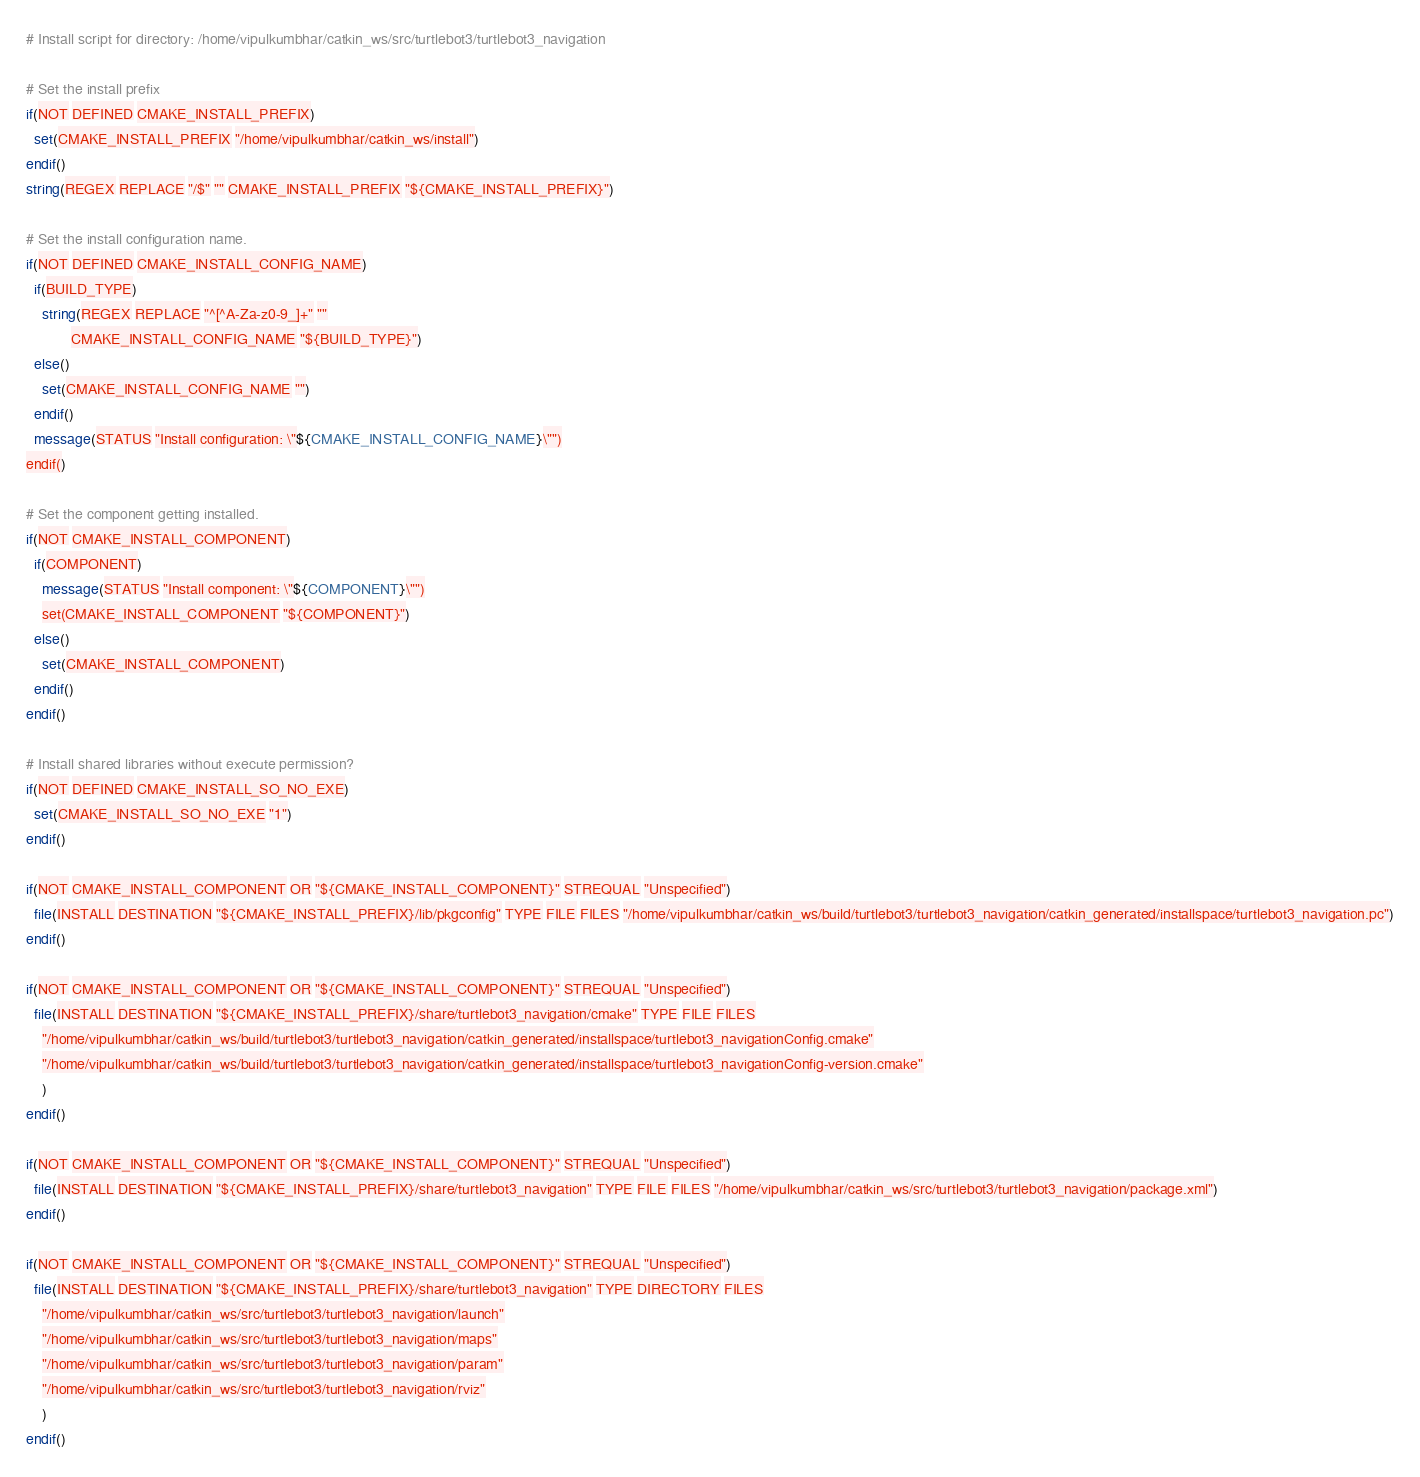Convert code to text. <code><loc_0><loc_0><loc_500><loc_500><_CMake_># Install script for directory: /home/vipulkumbhar/catkin_ws/src/turtlebot3/turtlebot3_navigation

# Set the install prefix
if(NOT DEFINED CMAKE_INSTALL_PREFIX)
  set(CMAKE_INSTALL_PREFIX "/home/vipulkumbhar/catkin_ws/install")
endif()
string(REGEX REPLACE "/$" "" CMAKE_INSTALL_PREFIX "${CMAKE_INSTALL_PREFIX}")

# Set the install configuration name.
if(NOT DEFINED CMAKE_INSTALL_CONFIG_NAME)
  if(BUILD_TYPE)
    string(REGEX REPLACE "^[^A-Za-z0-9_]+" ""
           CMAKE_INSTALL_CONFIG_NAME "${BUILD_TYPE}")
  else()
    set(CMAKE_INSTALL_CONFIG_NAME "")
  endif()
  message(STATUS "Install configuration: \"${CMAKE_INSTALL_CONFIG_NAME}\"")
endif()

# Set the component getting installed.
if(NOT CMAKE_INSTALL_COMPONENT)
  if(COMPONENT)
    message(STATUS "Install component: \"${COMPONENT}\"")
    set(CMAKE_INSTALL_COMPONENT "${COMPONENT}")
  else()
    set(CMAKE_INSTALL_COMPONENT)
  endif()
endif()

# Install shared libraries without execute permission?
if(NOT DEFINED CMAKE_INSTALL_SO_NO_EXE)
  set(CMAKE_INSTALL_SO_NO_EXE "1")
endif()

if(NOT CMAKE_INSTALL_COMPONENT OR "${CMAKE_INSTALL_COMPONENT}" STREQUAL "Unspecified")
  file(INSTALL DESTINATION "${CMAKE_INSTALL_PREFIX}/lib/pkgconfig" TYPE FILE FILES "/home/vipulkumbhar/catkin_ws/build/turtlebot3/turtlebot3_navigation/catkin_generated/installspace/turtlebot3_navigation.pc")
endif()

if(NOT CMAKE_INSTALL_COMPONENT OR "${CMAKE_INSTALL_COMPONENT}" STREQUAL "Unspecified")
  file(INSTALL DESTINATION "${CMAKE_INSTALL_PREFIX}/share/turtlebot3_navigation/cmake" TYPE FILE FILES
    "/home/vipulkumbhar/catkin_ws/build/turtlebot3/turtlebot3_navigation/catkin_generated/installspace/turtlebot3_navigationConfig.cmake"
    "/home/vipulkumbhar/catkin_ws/build/turtlebot3/turtlebot3_navigation/catkin_generated/installspace/turtlebot3_navigationConfig-version.cmake"
    )
endif()

if(NOT CMAKE_INSTALL_COMPONENT OR "${CMAKE_INSTALL_COMPONENT}" STREQUAL "Unspecified")
  file(INSTALL DESTINATION "${CMAKE_INSTALL_PREFIX}/share/turtlebot3_navigation" TYPE FILE FILES "/home/vipulkumbhar/catkin_ws/src/turtlebot3/turtlebot3_navigation/package.xml")
endif()

if(NOT CMAKE_INSTALL_COMPONENT OR "${CMAKE_INSTALL_COMPONENT}" STREQUAL "Unspecified")
  file(INSTALL DESTINATION "${CMAKE_INSTALL_PREFIX}/share/turtlebot3_navigation" TYPE DIRECTORY FILES
    "/home/vipulkumbhar/catkin_ws/src/turtlebot3/turtlebot3_navigation/launch"
    "/home/vipulkumbhar/catkin_ws/src/turtlebot3/turtlebot3_navigation/maps"
    "/home/vipulkumbhar/catkin_ws/src/turtlebot3/turtlebot3_navigation/param"
    "/home/vipulkumbhar/catkin_ws/src/turtlebot3/turtlebot3_navigation/rviz"
    )
endif()

</code> 